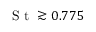<formula> <loc_0><loc_0><loc_500><loc_500>S t \gtrsim 0 . 7 7 5</formula> 